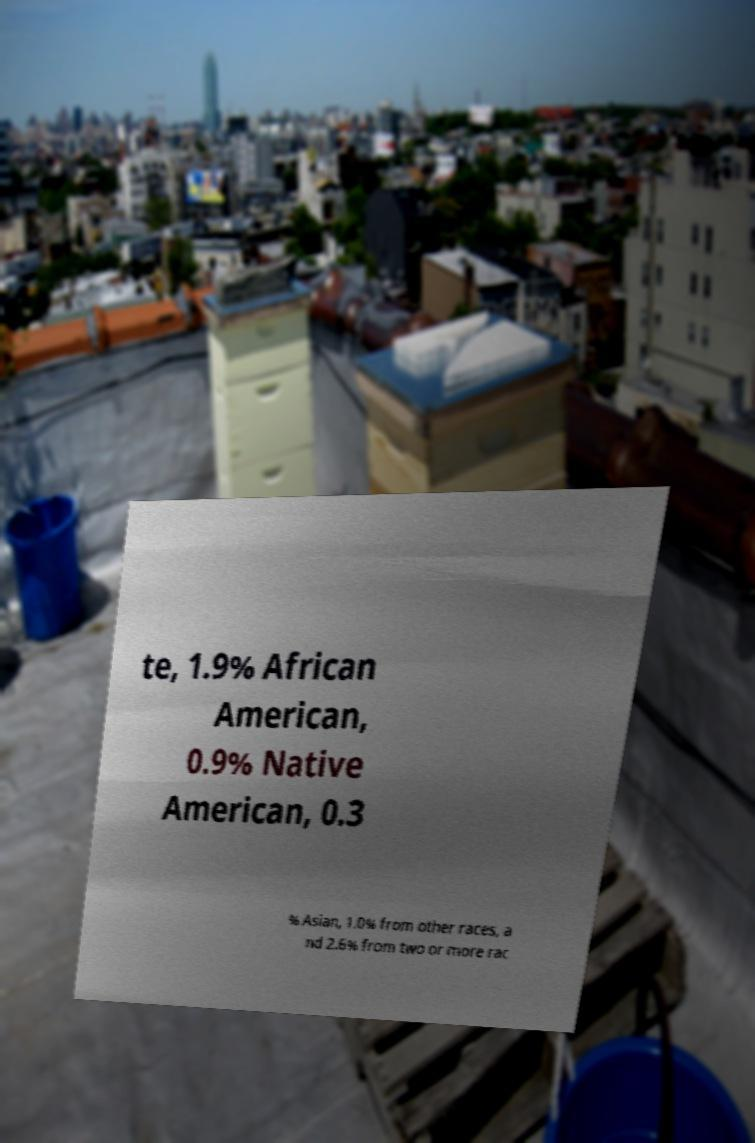For documentation purposes, I need the text within this image transcribed. Could you provide that? te, 1.9% African American, 0.9% Native American, 0.3 % Asian, 1.0% from other races, a nd 2.6% from two or more rac 